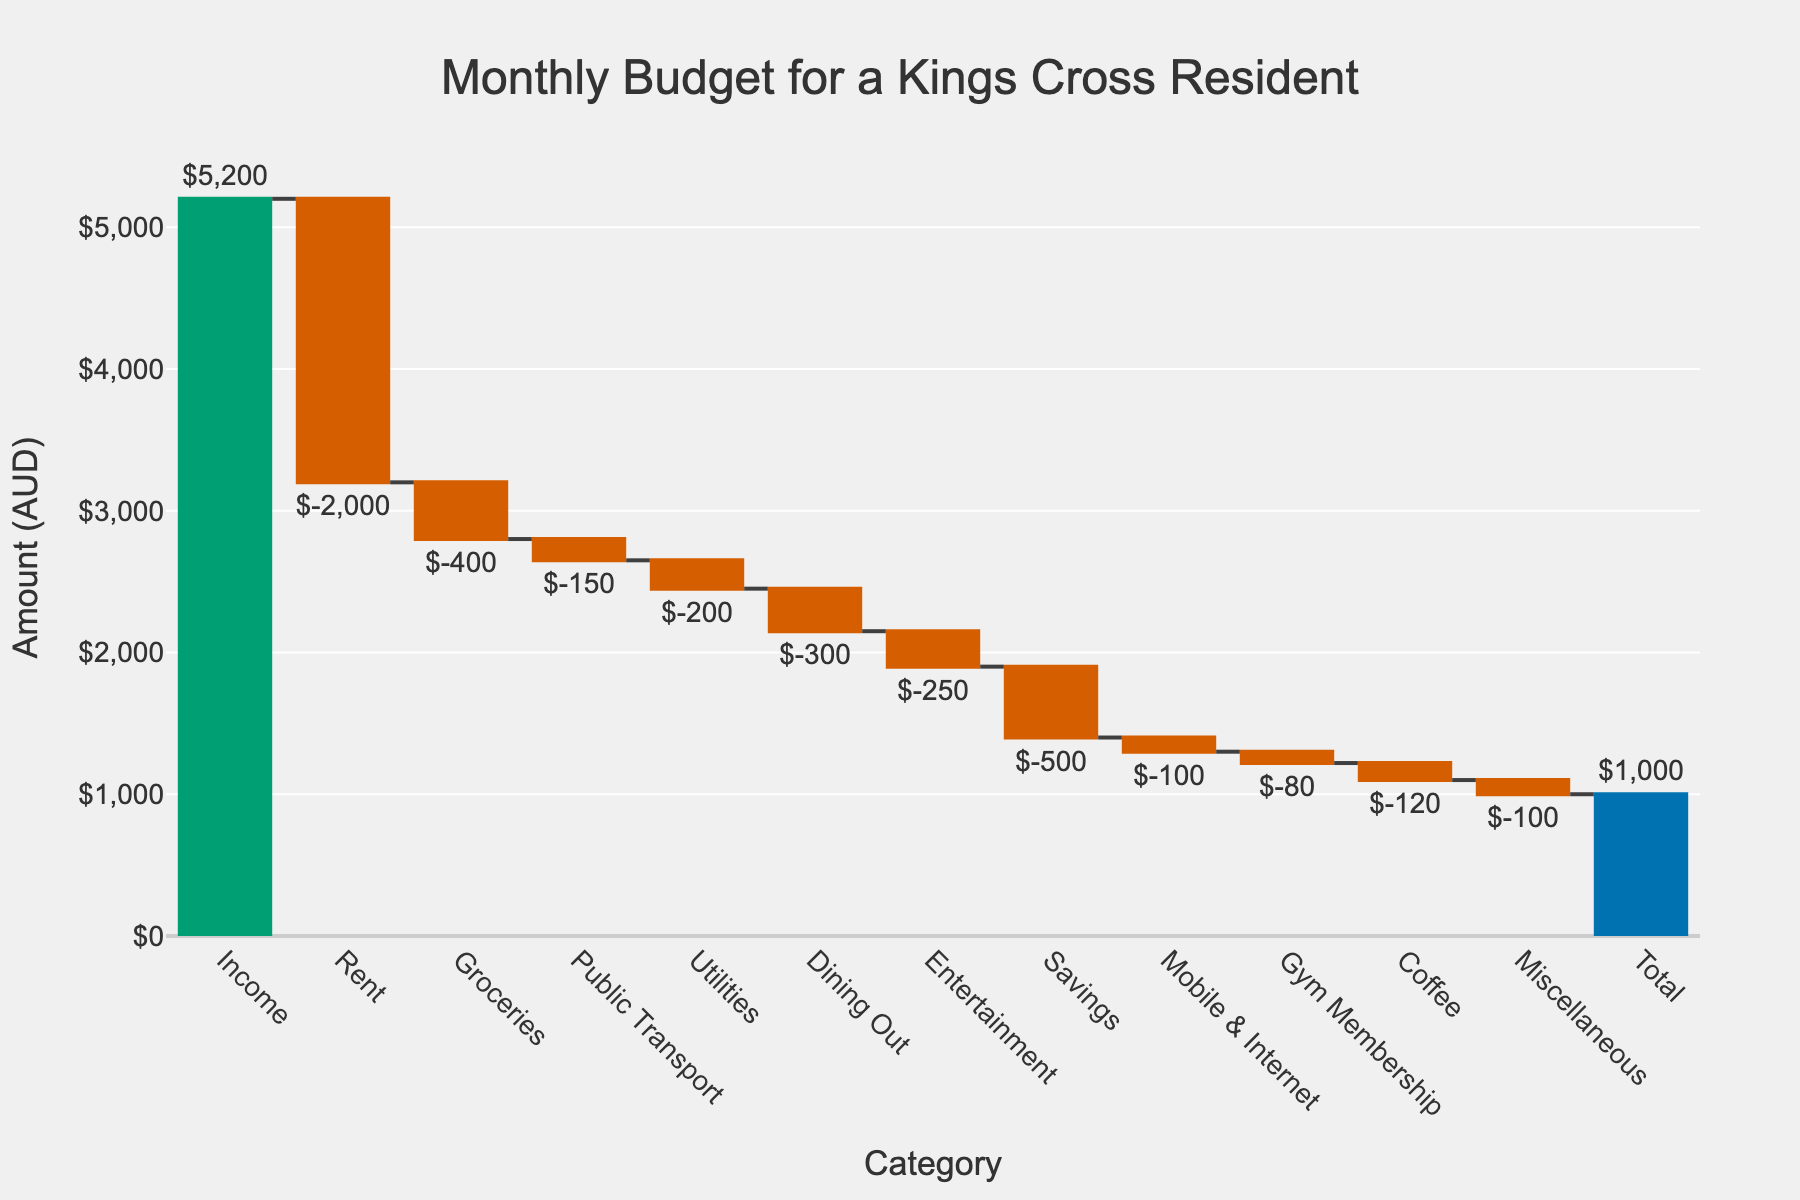What's the title of the chart? The title of the chart can be found at the top of the image, clearly indicating the overall topic. In this waterfall chart, it reads "Monthly Budget for a Kings Cross Resident".
Answer: Monthly Budget for a Kings Cross Resident How much is the income for the Kings Cross resident? The income value is the first bar in the waterfall chart and is labeled directly outside the bar. It is clearly marked with the amount of $5,200.
Answer: $5,200 What is the largest expense category for the Kings Cross resident? By observing the waterfall chart, the category with the largest downward bar (negative value) represents the largest expense. Here, "Rent" has the largest negative value, amounting to -$2,000.
Answer: Rent What is the net remaining amount (total) after all expenses and savings? The net remaining amount or total is indicated by the final bar in the waterfall chart. It shows a total of $1,000, as labeled outside the bar.
Answer: $1,000 Which two expense categories have the smallest contributions? By looking at the relatively smaller downward bars, "Gym Membership" and "Miscellaneous" are the categories with the smallest contributions, both marked with values of -$80 and -$100, respectively.
Answer: Gym Membership and Miscellaneous How much is spent on public transport and coffee combined? To find the combined amount for public transport and coffee, we sum the individual amounts for these categories. Public Transport is -$150, and Coffee is -$120. Summing these, the total is -$150 - $120 = -$270.
Answer: $-270 What is the difference between the spending on groceries and dining out? To find the difference, we compare the amounts spent. Groceries cost -$400, while Dining Out costs -$300. The difference is -$400 - (-$300) = -$100.
Answer: $100 What is the cumulative effect of the first three expense categories? The first three expense categories are Rent, Groceries, and Public Transport. Summing these quantities gives -$2,000 + -$400 + -$150 = -$2,550.
Answer: $-2,550 Which category lies between Utilities and Entertainment in terms of expenditure amount? By checking the chart values, the category that falls between the expenditures for Utilities (-$200) and Entertainment (-$250) is Dining Out, which is -$300.
Answer: Dining Out What percentage of the total income is saved by the Kings Cross resident? The savings amount is $500 out of the total income of $5,200. To calculate the percentage, we use the formula (Savings / Income) * 100. Hence, (500 / 5200) * 100 = approximately 9.62%.
Answer: 9.62% 